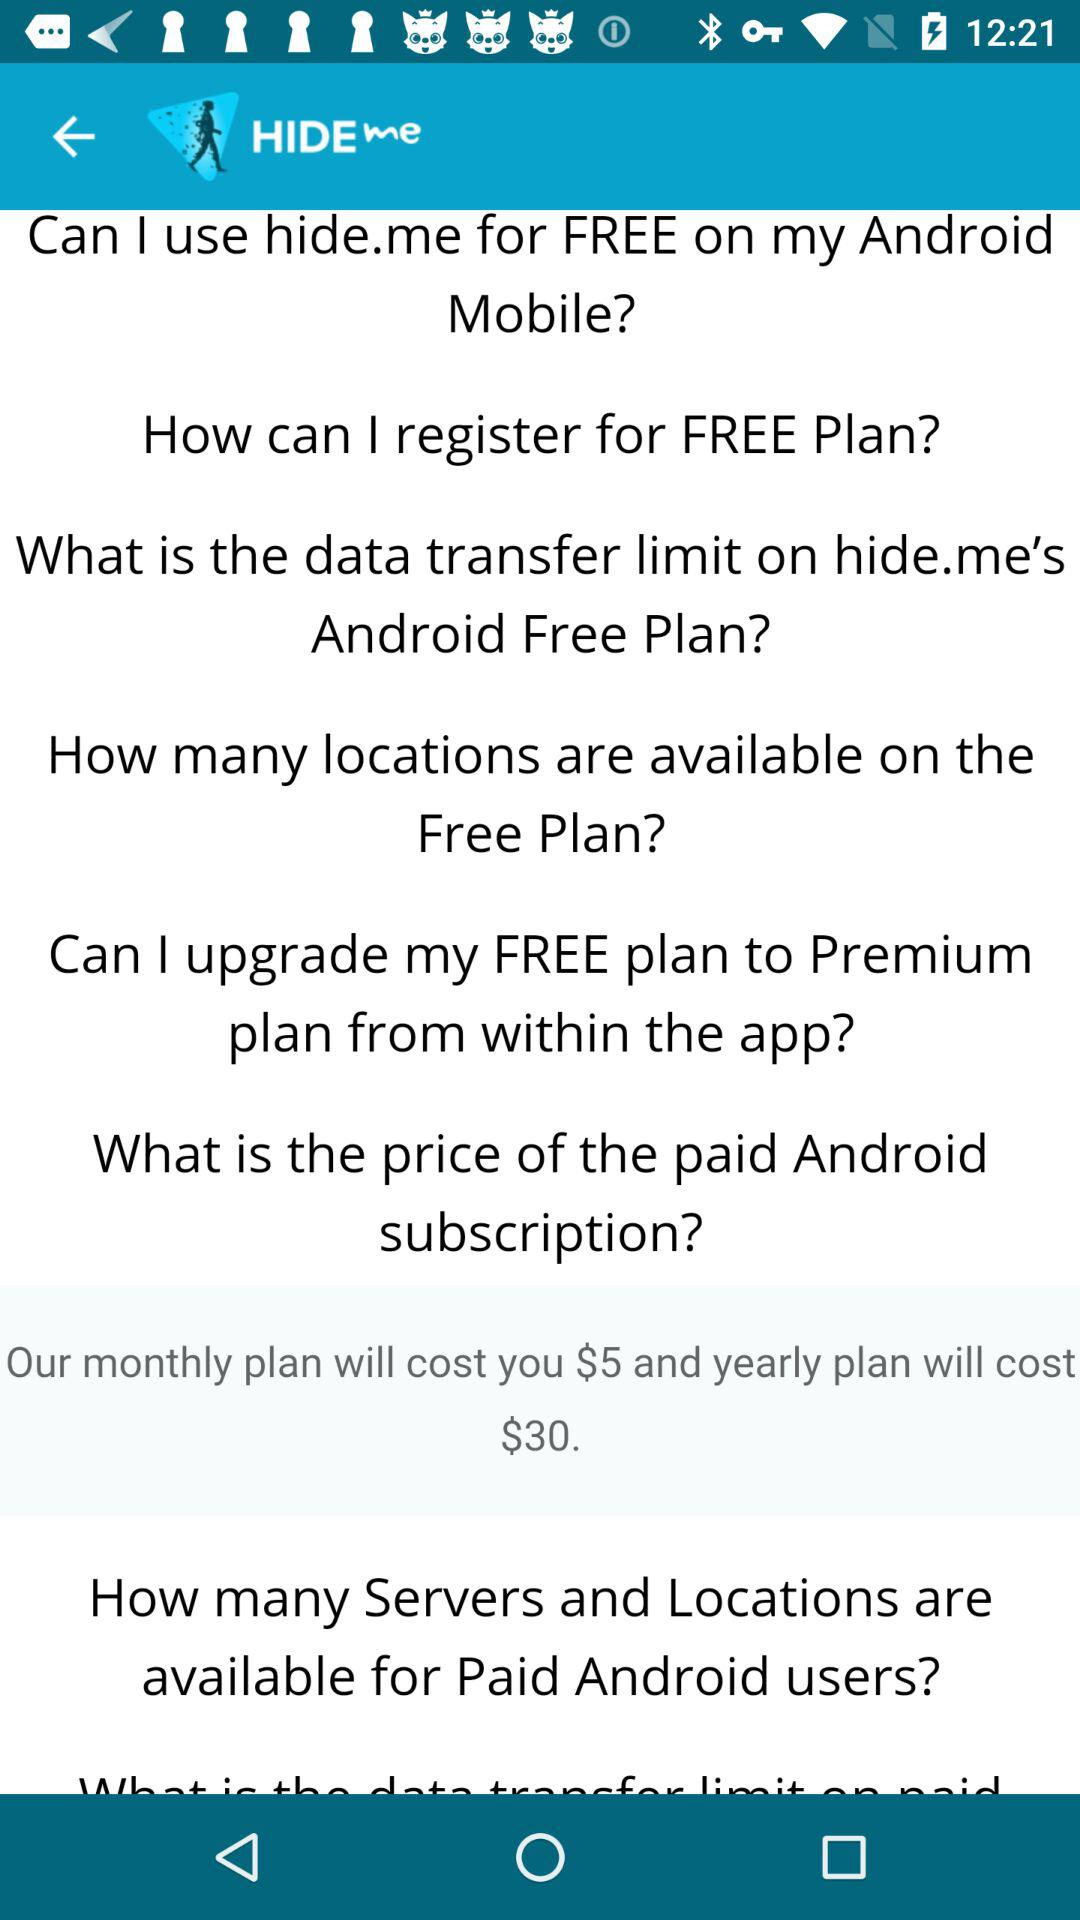What is the cost of the monthly plan? The cost of the monthly plan is $5. 